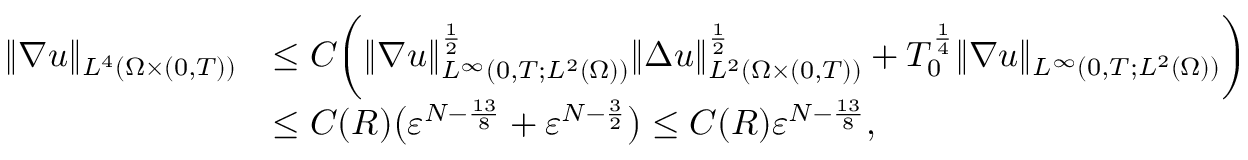Convert formula to latex. <formula><loc_0><loc_0><loc_500><loc_500>\begin{array} { r l } { \| \nabla u \| _ { L ^ { 4 } ( \Omega \times ( 0 , T ) ) } } & { \leq C \left ( \| \nabla u \| _ { L ^ { \infty } ( 0 , T ; L ^ { 2 } ( \Omega ) ) } ^ { \frac { 1 } { 2 } } \| \Delta u \| _ { L ^ { 2 } ( \Omega \times ( 0 , T ) ) } ^ { \frac { 1 } { 2 } } + T _ { 0 } ^ { \frac { 1 } { 4 } } \| \nabla u \| _ { L ^ { \infty } ( 0 , T ; L ^ { 2 } ( \Omega ) ) } \right ) } \\ & { \leq C ( R ) \left ( { \varepsilon } ^ { N - \frac { 1 3 } { 8 } } + { \varepsilon } ^ { N - \frac { 3 } { 2 } } \right ) \leq C ( R ) { \varepsilon } ^ { N - \frac { 1 3 } 8 } , } \end{array}</formula> 